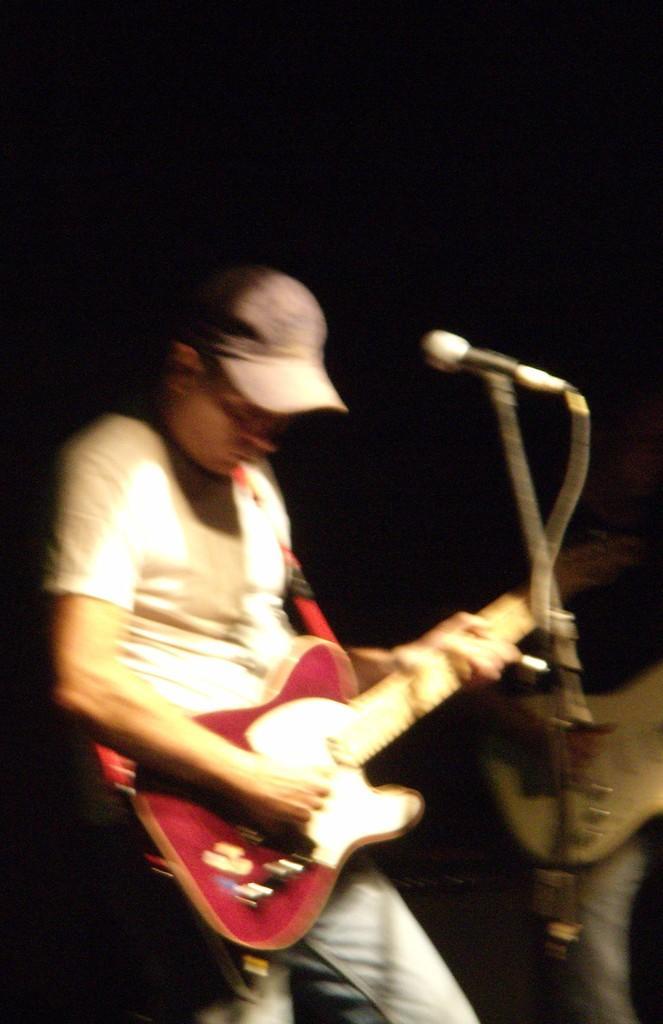Can you describe this image briefly? In this image there is a man who is standing and playing the guitar with his hand and their is a mic in front of him. In the background there is another man who is also playing the guitar. 